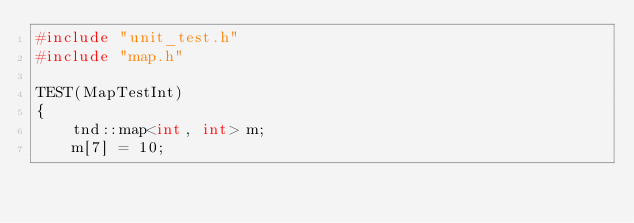<code> <loc_0><loc_0><loc_500><loc_500><_C++_>#include "unit_test.h"
#include "map.h"

TEST(MapTestInt)
{
    tnd::map<int, int> m;
    m[7] = 10;</code> 